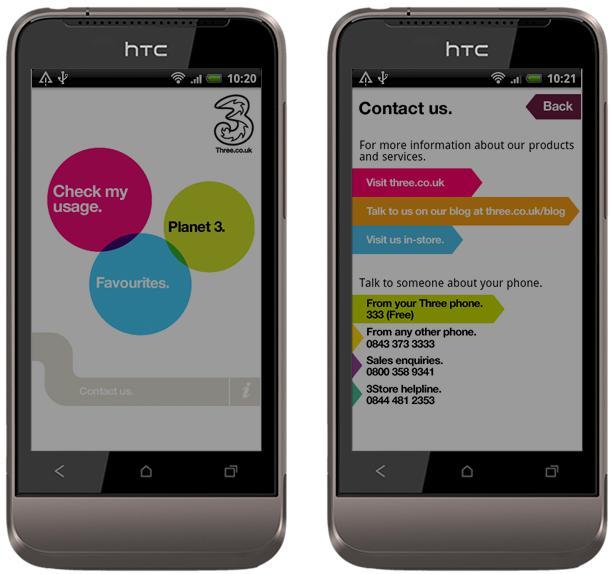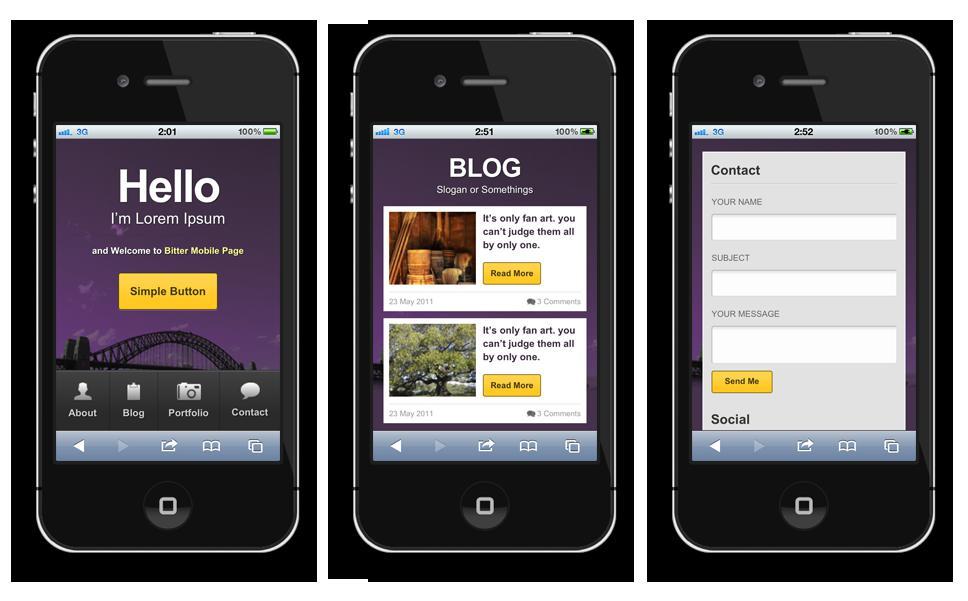The first image is the image on the left, the second image is the image on the right. Considering the images on both sides, is "One of the images shows a cell phone that has three differently colored circles on the screen." valid? Answer yes or no. Yes. The first image is the image on the left, the second image is the image on the right. Examine the images to the left and right. Is the description "One image shows two side by side phones displayed screen-first and head-on, and the other image shows a row of three screen-first phones that are not overlapping." accurate? Answer yes or no. Yes. 